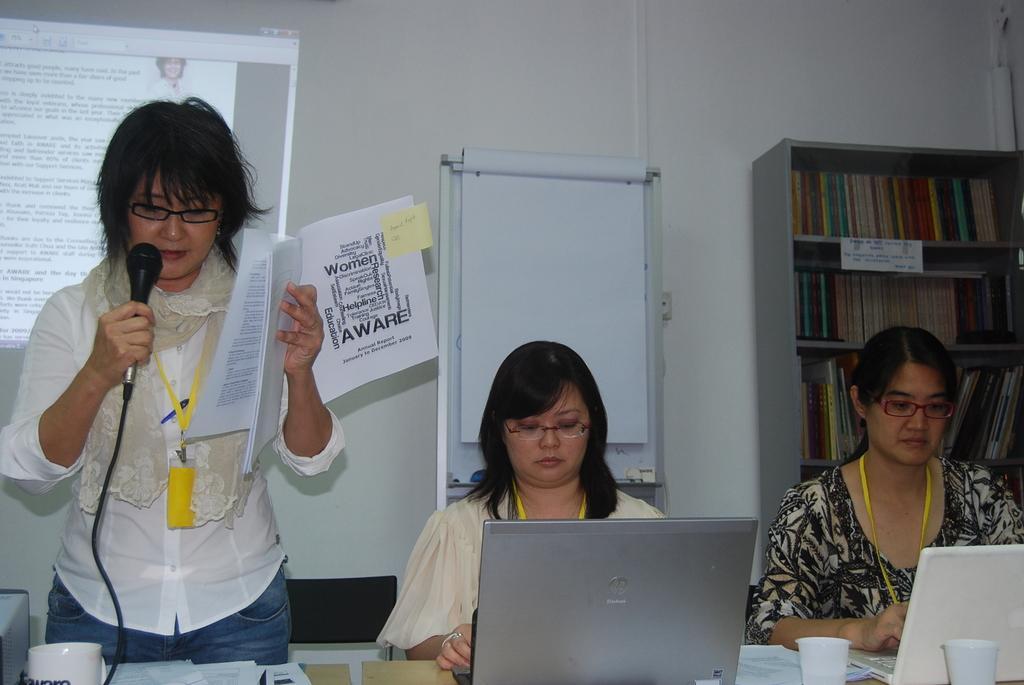Please provide a concise description of this image. In this image we can see three women wearing spectacles and id cards. One woman is holding paper in her hand and a microphone in other hand, standing in front of a table on which group of papers and a cup are placed. In the foreground we can see two laptops and two cups placed on the table. In the background, we can see group of books placed in a rack and a screen. 